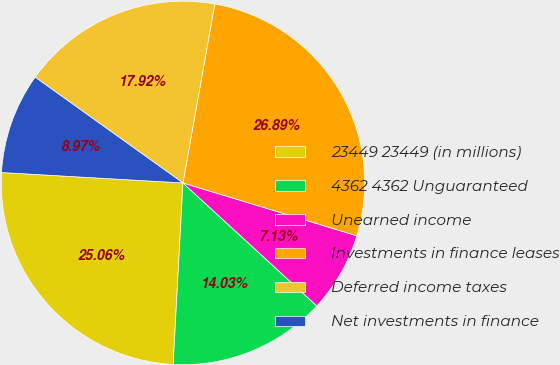<chart> <loc_0><loc_0><loc_500><loc_500><pie_chart><fcel>23449 23449 (in millions)<fcel>4362 4362 Unguaranteed<fcel>Unearned income<fcel>Investments in finance leases<fcel>Deferred income taxes<fcel>Net investments in finance<nl><fcel>25.06%<fcel>14.03%<fcel>7.13%<fcel>26.89%<fcel>17.92%<fcel>8.97%<nl></chart> 